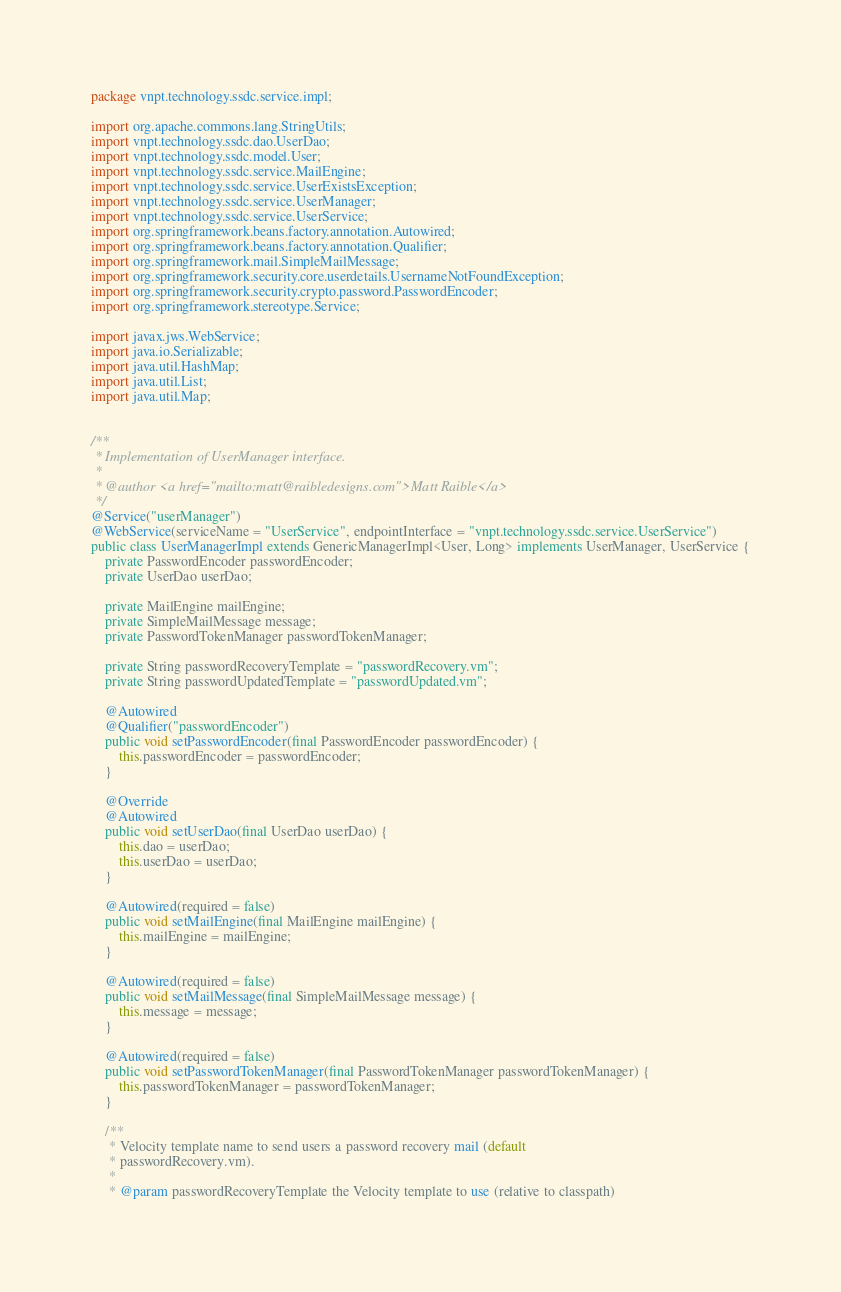Convert code to text. <code><loc_0><loc_0><loc_500><loc_500><_Java_>package vnpt.technology.ssdc.service.impl;

import org.apache.commons.lang.StringUtils;
import vnpt.technology.ssdc.dao.UserDao;
import vnpt.technology.ssdc.model.User;
import vnpt.technology.ssdc.service.MailEngine;
import vnpt.technology.ssdc.service.UserExistsException;
import vnpt.technology.ssdc.service.UserManager;
import vnpt.technology.ssdc.service.UserService;
import org.springframework.beans.factory.annotation.Autowired;
import org.springframework.beans.factory.annotation.Qualifier;
import org.springframework.mail.SimpleMailMessage;
import org.springframework.security.core.userdetails.UsernameNotFoundException;
import org.springframework.security.crypto.password.PasswordEncoder;
import org.springframework.stereotype.Service;

import javax.jws.WebService;
import java.io.Serializable;
import java.util.HashMap;
import java.util.List;
import java.util.Map;


/**
 * Implementation of UserManager interface.
 *
 * @author <a href="mailto:matt@raibledesigns.com">Matt Raible</a>
 */
@Service("userManager")
@WebService(serviceName = "UserService", endpointInterface = "vnpt.technology.ssdc.service.UserService")
public class UserManagerImpl extends GenericManagerImpl<User, Long> implements UserManager, UserService {
    private PasswordEncoder passwordEncoder;
    private UserDao userDao;

    private MailEngine mailEngine;
    private SimpleMailMessage message;
    private PasswordTokenManager passwordTokenManager;

    private String passwordRecoveryTemplate = "passwordRecovery.vm";
    private String passwordUpdatedTemplate = "passwordUpdated.vm";

    @Autowired
    @Qualifier("passwordEncoder")
    public void setPasswordEncoder(final PasswordEncoder passwordEncoder) {
        this.passwordEncoder = passwordEncoder;
    }

    @Override
    @Autowired
    public void setUserDao(final UserDao userDao) {
        this.dao = userDao;
        this.userDao = userDao;
    }

    @Autowired(required = false)
    public void setMailEngine(final MailEngine mailEngine) {
        this.mailEngine = mailEngine;
    }

    @Autowired(required = false)
    public void setMailMessage(final SimpleMailMessage message) {
        this.message = message;
    }

    @Autowired(required = false)
    public void setPasswordTokenManager(final PasswordTokenManager passwordTokenManager) {
        this.passwordTokenManager = passwordTokenManager;
    }

    /**
     * Velocity template name to send users a password recovery mail (default
     * passwordRecovery.vm).
     *
     * @param passwordRecoveryTemplate the Velocity template to use (relative to classpath)</code> 